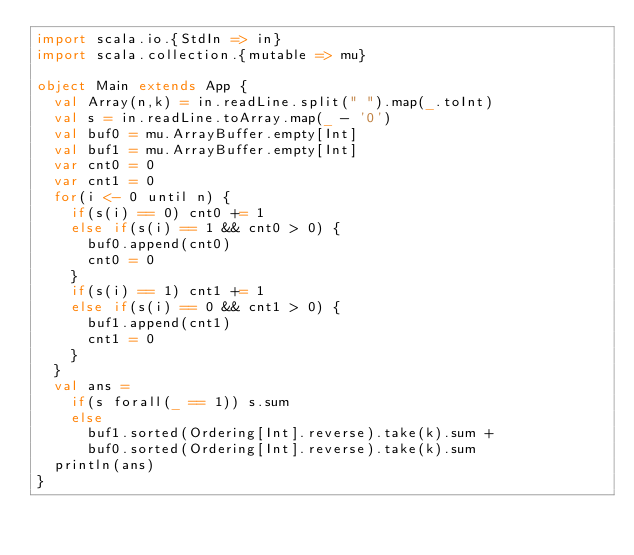Convert code to text. <code><loc_0><loc_0><loc_500><loc_500><_Scala_>import scala.io.{StdIn => in}
import scala.collection.{mutable => mu}

object Main extends App {
  val Array(n,k) = in.readLine.split(" ").map(_.toInt)
  val s = in.readLine.toArray.map(_ - '0')
  val buf0 = mu.ArrayBuffer.empty[Int]
  val buf1 = mu.ArrayBuffer.empty[Int]
  var cnt0 = 0
  var cnt1 = 0
  for(i <- 0 until n) {
    if(s(i) == 0) cnt0 += 1
    else if(s(i) == 1 && cnt0 > 0) {
      buf0.append(cnt0)
      cnt0 = 0
    }
    if(s(i) == 1) cnt1 += 1
    else if(s(i) == 0 && cnt1 > 0) {
      buf1.append(cnt1)
      cnt1 = 0
    }
  }
  val ans =
    if(s forall(_ == 1)) s.sum
    else
      buf1.sorted(Ordering[Int].reverse).take(k).sum +
      buf0.sorted(Ordering[Int].reverse).take(k).sum
  println(ans)
}</code> 